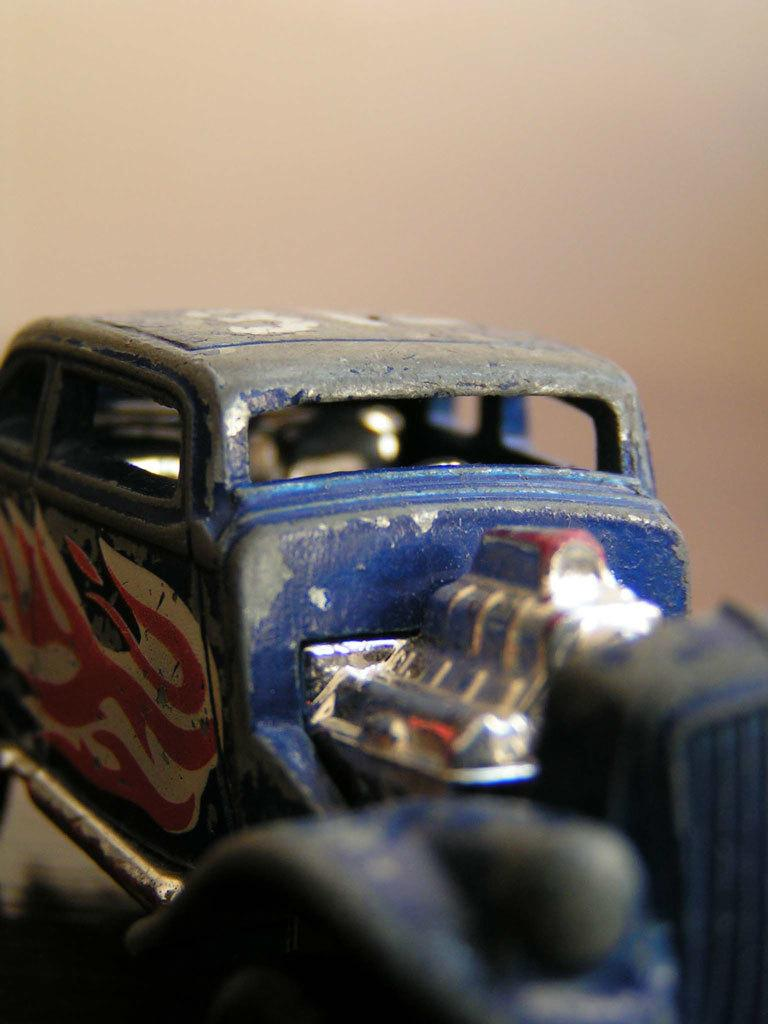What object is present in the image that resembles a vehicle? There is a toy vehicle in the image. On what surface is the toy vehicle placed? The toy vehicle is placed on a surface. How many babies are crawling around the toy vehicle in the image? There are no babies present in the image; it only features a toy vehicle placed on a surface. 